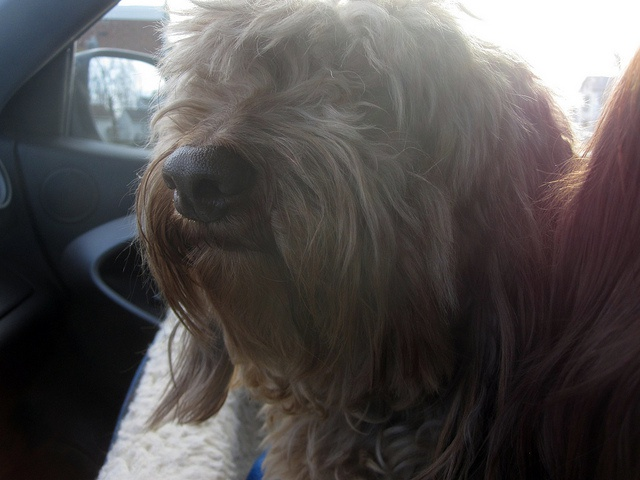Describe the objects in this image and their specific colors. I can see dog in black, gray, and darkgray tones and people in gray, black, and brown tones in this image. 